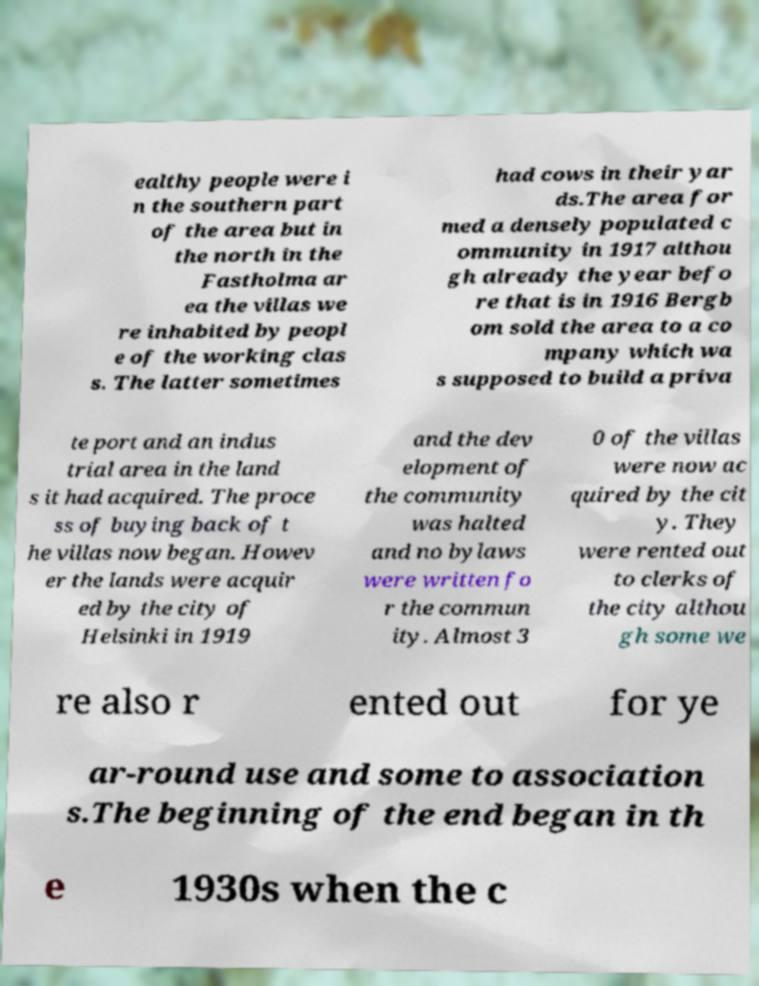Can you accurately transcribe the text from the provided image for me? ealthy people were i n the southern part of the area but in the north in the Fastholma ar ea the villas we re inhabited by peopl e of the working clas s. The latter sometimes had cows in their yar ds.The area for med a densely populated c ommunity in 1917 althou gh already the year befo re that is in 1916 Bergb om sold the area to a co mpany which wa s supposed to build a priva te port and an indus trial area in the land s it had acquired. The proce ss of buying back of t he villas now began. Howev er the lands were acquir ed by the city of Helsinki in 1919 and the dev elopment of the community was halted and no bylaws were written fo r the commun ity. Almost 3 0 of the villas were now ac quired by the cit y. They were rented out to clerks of the city althou gh some we re also r ented out for ye ar-round use and some to association s.The beginning of the end began in th e 1930s when the c 